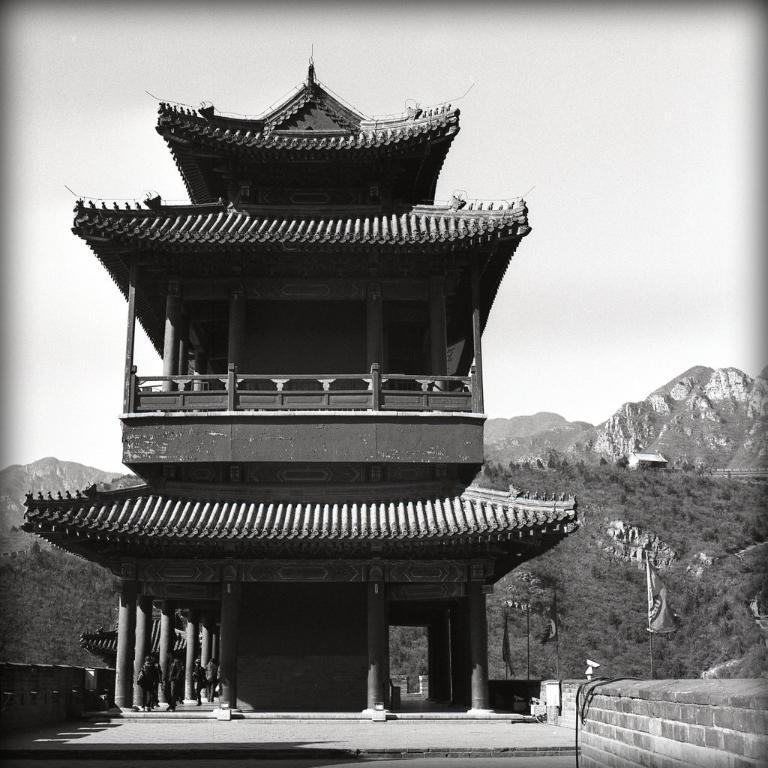What is the primary setting of the image? There are people on the ground in the image. What type of structure can be seen in the image? There is a building in the image. What type of barrier is present in the image? There is a fence in the image. What type of decorative or symbolic items are present in the image? There are flags in the image. What type of architectural feature can be seen in the image? There is a wall in the image. What type of objects are present in the image? There are objects in the image. What type of natural elements can be seen in the background of the image? There are trees and mountains in the background of the image. What type of sky is visible in the background of the image? There is sky visible in the background of the image. How does the fireman control the scarf in the image? There is no fireman or scarf present in the image. What type of clothing is the fireman wearing in the image? There is no fireman present in the image, so it is not possible to answer this question. 